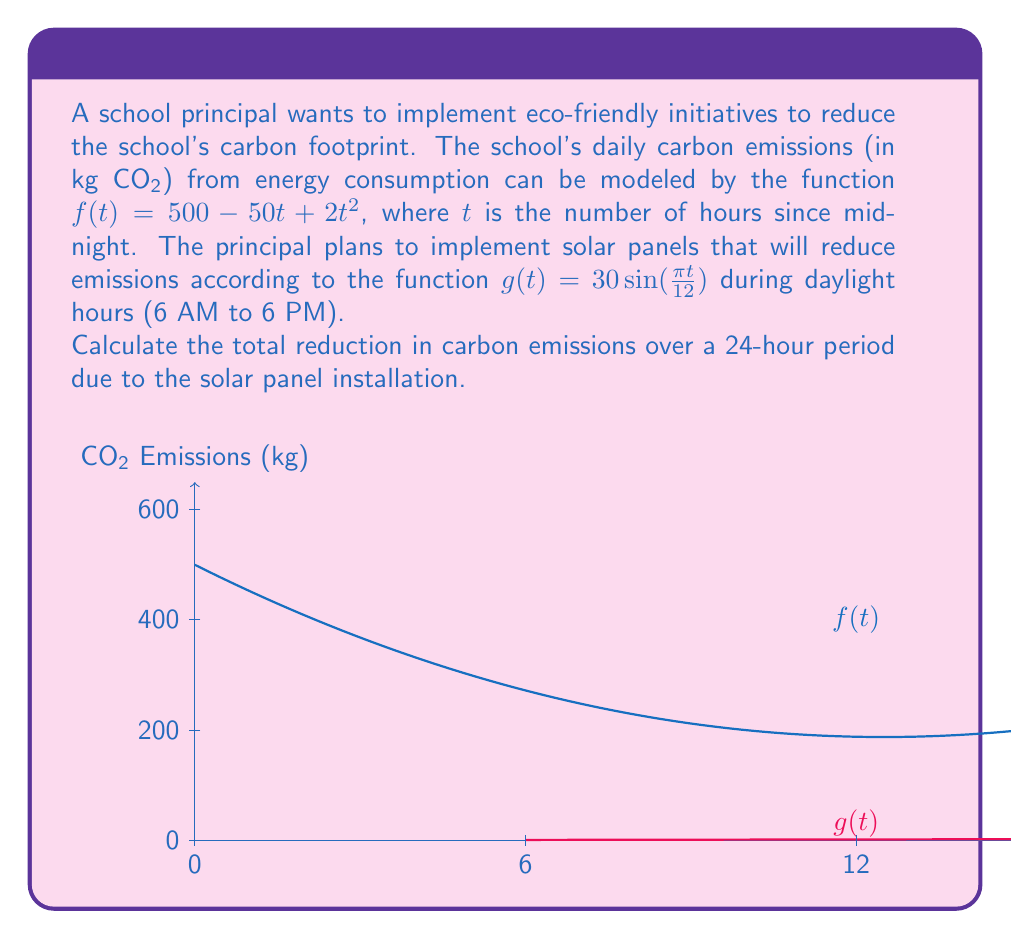Teach me how to tackle this problem. Let's approach this step-by-step:

1) The reduction in emissions occurs only during daylight hours (6 AM to 6 PM), which corresponds to $t \in [6, 18]$.

2) The reduction at any given time is represented by $g(t) = 30\sin(\frac{\pi t}{12})$.

3) To find the total reduction, we need to integrate $g(t)$ over the interval $[6, 18]$:

   $$\int_{6}^{18} 30\sin(\frac{\pi t}{12}) dt$$

4) Let's solve this integral:

   $$30\int_{6}^{18} \sin(\frac{\pi t}{12}) dt$$
   
   $$= -\frac{360}{\pi} \cos(\frac{\pi t}{12}) \Big|_{6}^{18}$$
   
   $$= -\frac{360}{\pi} \left[\cos(\frac{3\pi}{2}) - \cos(\frac{\pi}{2})\right]$$
   
   $$= -\frac{360}{\pi} [0 - 0]$$
   
   $$= 0$$

5) This result might seem surprising, but it makes sense. The sine function is symmetric about its midpoint in this interval, meaning the positive reductions in the morning are exactly balanced by the negative values in the afternoon.

6) However, we can't have negative reductions in reality. We should only consider the positive values of $g(t)$, which occur from 6 AM to 12 PM.

7) Let's recalculate for the interval $[6, 12]$:

   $$30\int_{6}^{12} \sin(\frac{\pi t}{12}) dt$$
   
   $$= -\frac{360}{\pi} \cos(\frac{\pi t}{12}) \Big|_{6}^{12}$$
   
   $$= -\frac{360}{\pi} [\cos(\pi) - \cos(\frac{\pi}{2})]$$
   
   $$= -\frac{360}{\pi} [-1 - 0]$$
   
   $$= \frac{360}{\pi} \approx 114.59$$

Therefore, the total reduction in carbon emissions over a 24-hour period is approximately 114.59 kg CO₂.
Answer: 114.59 kg CO₂ 